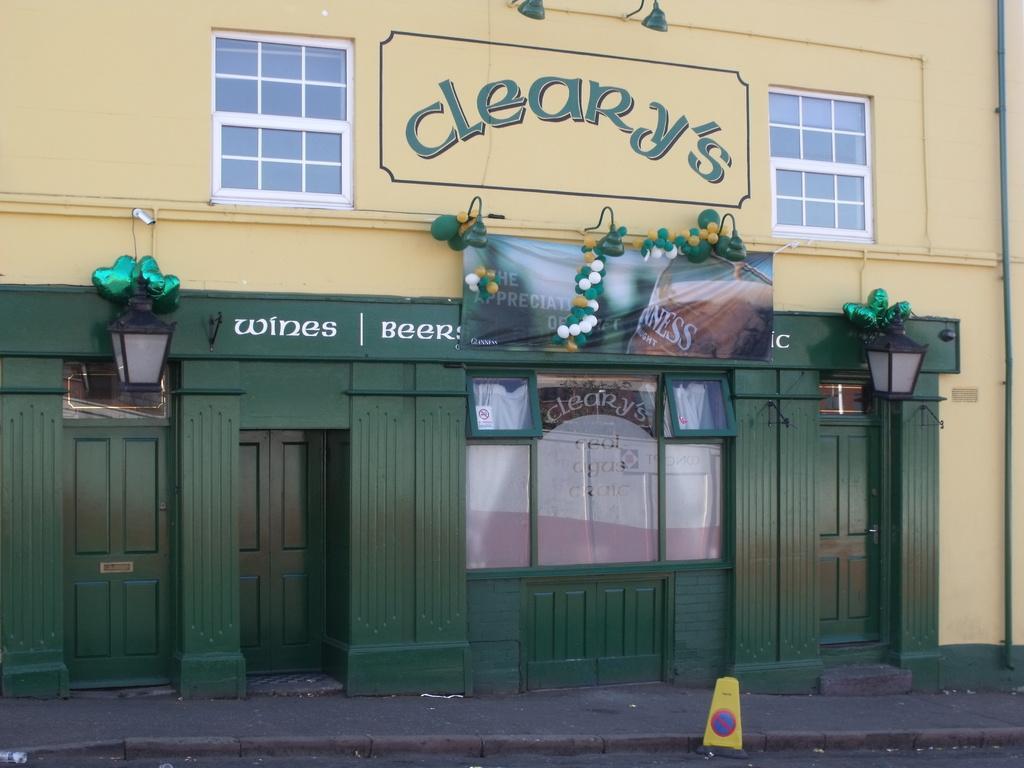How would you summarize this image in a sentence or two? This looks like a building with the doors and windows. These are the lamps. This looks like a banner, which is hanging. I think these are the balloons. I can see a signboard, which is placed on the road. 